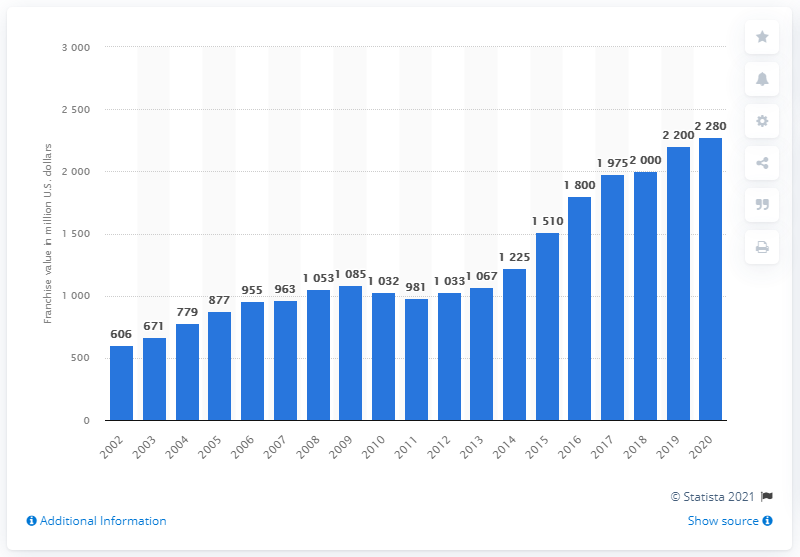Draw attention to some important aspects in this diagram. The value of the Tampa Bay Buccaneers in 2020 was approximately $2,280 in United States dollars. 